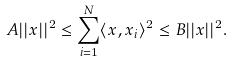<formula> <loc_0><loc_0><loc_500><loc_500>A | | x | | ^ { 2 } \leq \sum _ { i = 1 } ^ { N } \langle x , x _ { i } \rangle ^ { 2 } \leq B | | x | | ^ { 2 } .</formula> 